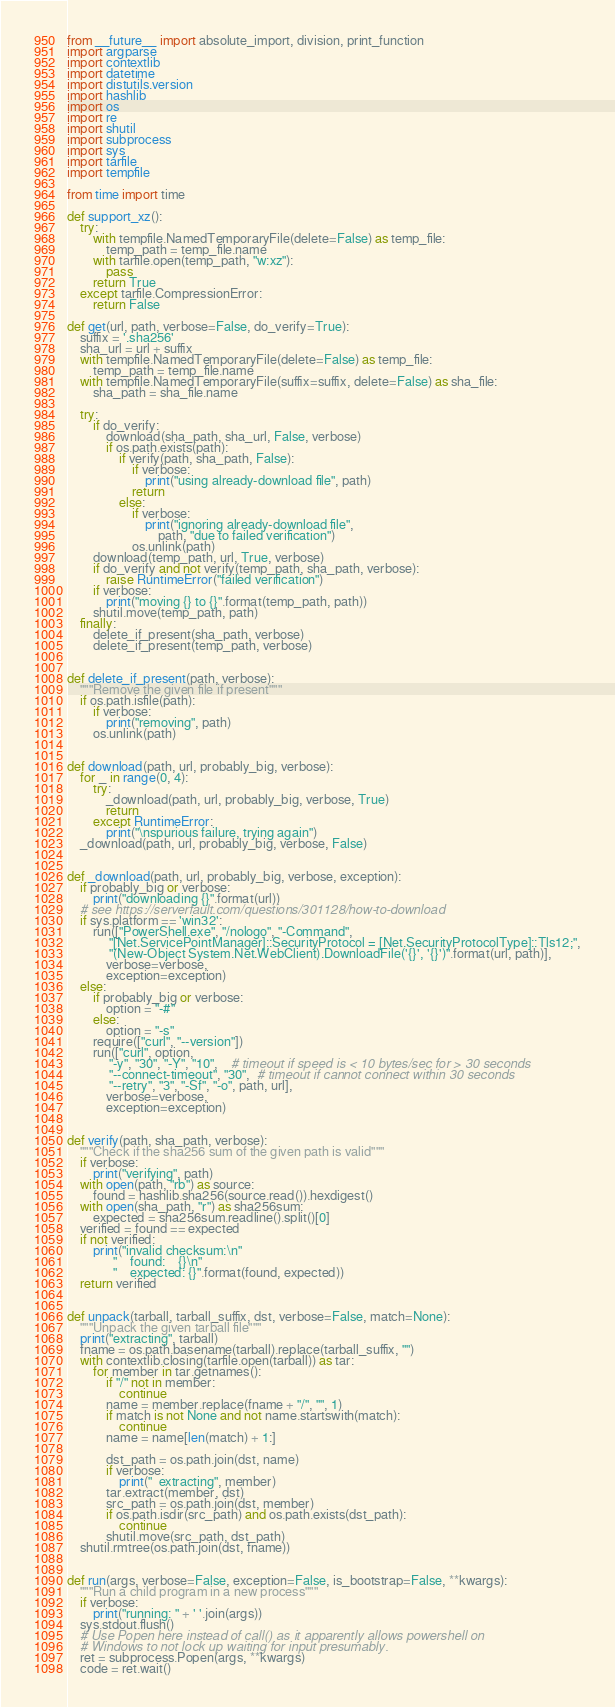<code> <loc_0><loc_0><loc_500><loc_500><_Python_>from __future__ import absolute_import, division, print_function
import argparse
import contextlib
import datetime
import distutils.version
import hashlib
import os
import re
import shutil
import subprocess
import sys
import tarfile
import tempfile

from time import time

def support_xz():
    try:
        with tempfile.NamedTemporaryFile(delete=False) as temp_file:
            temp_path = temp_file.name
        with tarfile.open(temp_path, "w:xz"):
            pass
        return True
    except tarfile.CompressionError:
        return False

def get(url, path, verbose=False, do_verify=True):
    suffix = '.sha256'
    sha_url = url + suffix
    with tempfile.NamedTemporaryFile(delete=False) as temp_file:
        temp_path = temp_file.name
    with tempfile.NamedTemporaryFile(suffix=suffix, delete=False) as sha_file:
        sha_path = sha_file.name

    try:
        if do_verify:
            download(sha_path, sha_url, False, verbose)
            if os.path.exists(path):
                if verify(path, sha_path, False):
                    if verbose:
                        print("using already-download file", path)
                    return
                else:
                    if verbose:
                        print("ignoring already-download file",
                            path, "due to failed verification")
                    os.unlink(path)
        download(temp_path, url, True, verbose)
        if do_verify and not verify(temp_path, sha_path, verbose):
            raise RuntimeError("failed verification")
        if verbose:
            print("moving {} to {}".format(temp_path, path))
        shutil.move(temp_path, path)
    finally:
        delete_if_present(sha_path, verbose)
        delete_if_present(temp_path, verbose)


def delete_if_present(path, verbose):
    """Remove the given file if present"""
    if os.path.isfile(path):
        if verbose:
            print("removing", path)
        os.unlink(path)


def download(path, url, probably_big, verbose):
    for _ in range(0, 4):
        try:
            _download(path, url, probably_big, verbose, True)
            return
        except RuntimeError:
            print("\nspurious failure, trying again")
    _download(path, url, probably_big, verbose, False)


def _download(path, url, probably_big, verbose, exception):
    if probably_big or verbose:
        print("downloading {}".format(url))
    # see https://serverfault.com/questions/301128/how-to-download
    if sys.platform == 'win32':
        run(["PowerShell.exe", "/nologo", "-Command",
             "[Net.ServicePointManager]::SecurityProtocol = [Net.SecurityProtocolType]::Tls12;",
             "(New-Object System.Net.WebClient).DownloadFile('{}', '{}')".format(url, path)],
            verbose=verbose,
            exception=exception)
    else:
        if probably_big or verbose:
            option = "-#"
        else:
            option = "-s"
        require(["curl", "--version"])
        run(["curl", option,
             "-y", "30", "-Y", "10",    # timeout if speed is < 10 bytes/sec for > 30 seconds
             "--connect-timeout", "30",  # timeout if cannot connect within 30 seconds
             "--retry", "3", "-Sf", "-o", path, url],
            verbose=verbose,
            exception=exception)


def verify(path, sha_path, verbose):
    """Check if the sha256 sum of the given path is valid"""
    if verbose:
        print("verifying", path)
    with open(path, "rb") as source:
        found = hashlib.sha256(source.read()).hexdigest()
    with open(sha_path, "r") as sha256sum:
        expected = sha256sum.readline().split()[0]
    verified = found == expected
    if not verified:
        print("invalid checksum:\n"
              "    found:    {}\n"
              "    expected: {}".format(found, expected))
    return verified


def unpack(tarball, tarball_suffix, dst, verbose=False, match=None):
    """Unpack the given tarball file"""
    print("extracting", tarball)
    fname = os.path.basename(tarball).replace(tarball_suffix, "")
    with contextlib.closing(tarfile.open(tarball)) as tar:
        for member in tar.getnames():
            if "/" not in member:
                continue
            name = member.replace(fname + "/", "", 1)
            if match is not None and not name.startswith(match):
                continue
            name = name[len(match) + 1:]

            dst_path = os.path.join(dst, name)
            if verbose:
                print("  extracting", member)
            tar.extract(member, dst)
            src_path = os.path.join(dst, member)
            if os.path.isdir(src_path) and os.path.exists(dst_path):
                continue
            shutil.move(src_path, dst_path)
    shutil.rmtree(os.path.join(dst, fname))


def run(args, verbose=False, exception=False, is_bootstrap=False, **kwargs):
    """Run a child program in a new process"""
    if verbose:
        print("running: " + ' '.join(args))
    sys.stdout.flush()
    # Use Popen here instead of call() as it apparently allows powershell on
    # Windows to not lock up waiting for input presumably.
    ret = subprocess.Popen(args, **kwargs)
    code = ret.wait()</code> 